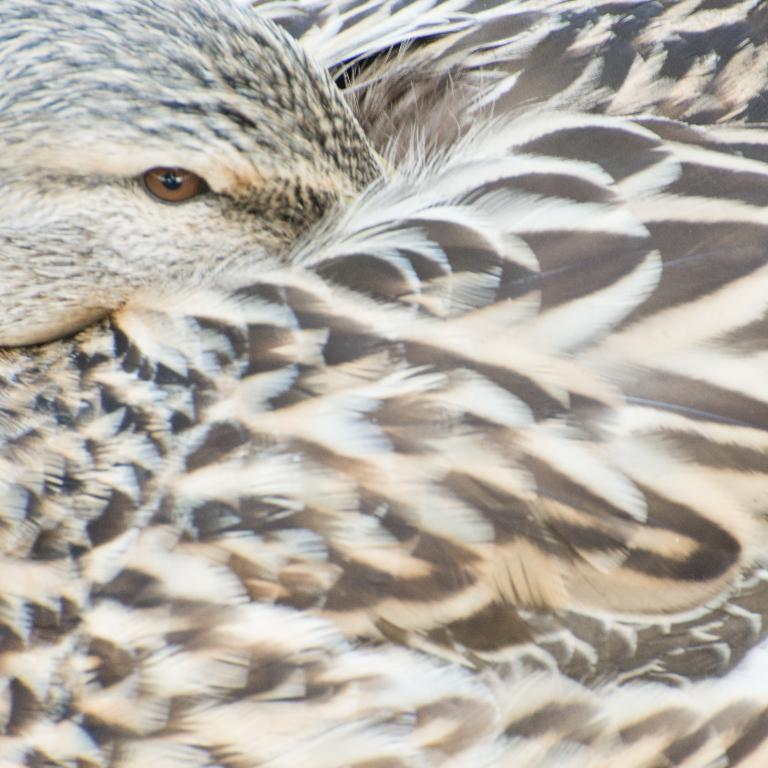What type of animal can be seen in the image? There is a bird in the image. What type of soda is the bird drinking in the image? There is no soda present in the image, and therefore no such activity can be observed. 